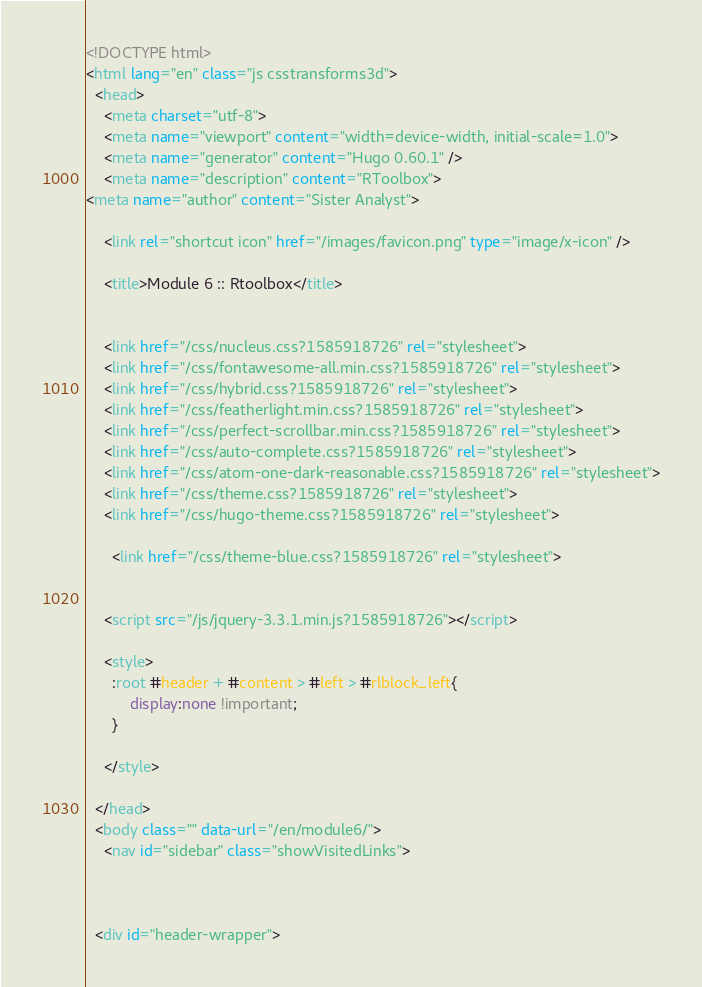<code> <loc_0><loc_0><loc_500><loc_500><_HTML_><!DOCTYPE html>
<html lang="en" class="js csstransforms3d">
  <head>
    <meta charset="utf-8">
    <meta name="viewport" content="width=device-width, initial-scale=1.0">
    <meta name="generator" content="Hugo 0.60.1" />
    <meta name="description" content="RToolbox">
<meta name="author" content="Sister Analyst">

    <link rel="shortcut icon" href="/images/favicon.png" type="image/x-icon" />

    <title>Module 6 :: Rtoolbox</title>

    
    <link href="/css/nucleus.css?1585918726" rel="stylesheet">
    <link href="/css/fontawesome-all.min.css?1585918726" rel="stylesheet">
    <link href="/css/hybrid.css?1585918726" rel="stylesheet">
    <link href="/css/featherlight.min.css?1585918726" rel="stylesheet">
    <link href="/css/perfect-scrollbar.min.css?1585918726" rel="stylesheet">
    <link href="/css/auto-complete.css?1585918726" rel="stylesheet">
    <link href="/css/atom-one-dark-reasonable.css?1585918726" rel="stylesheet">
    <link href="/css/theme.css?1585918726" rel="stylesheet">
    <link href="/css/hugo-theme.css?1585918726" rel="stylesheet">
    
      <link href="/css/theme-blue.css?1585918726" rel="stylesheet">
    

    <script src="/js/jquery-3.3.1.min.js?1585918726"></script>

    <style>
      :root #header + #content > #left > #rlblock_left{
          display:none !important;
      }
      
    </style>
    
  </head>
  <body class="" data-url="/en/module6/">
    <nav id="sidebar" class="showVisitedLinks">



  <div id="header-wrapper"></code> 